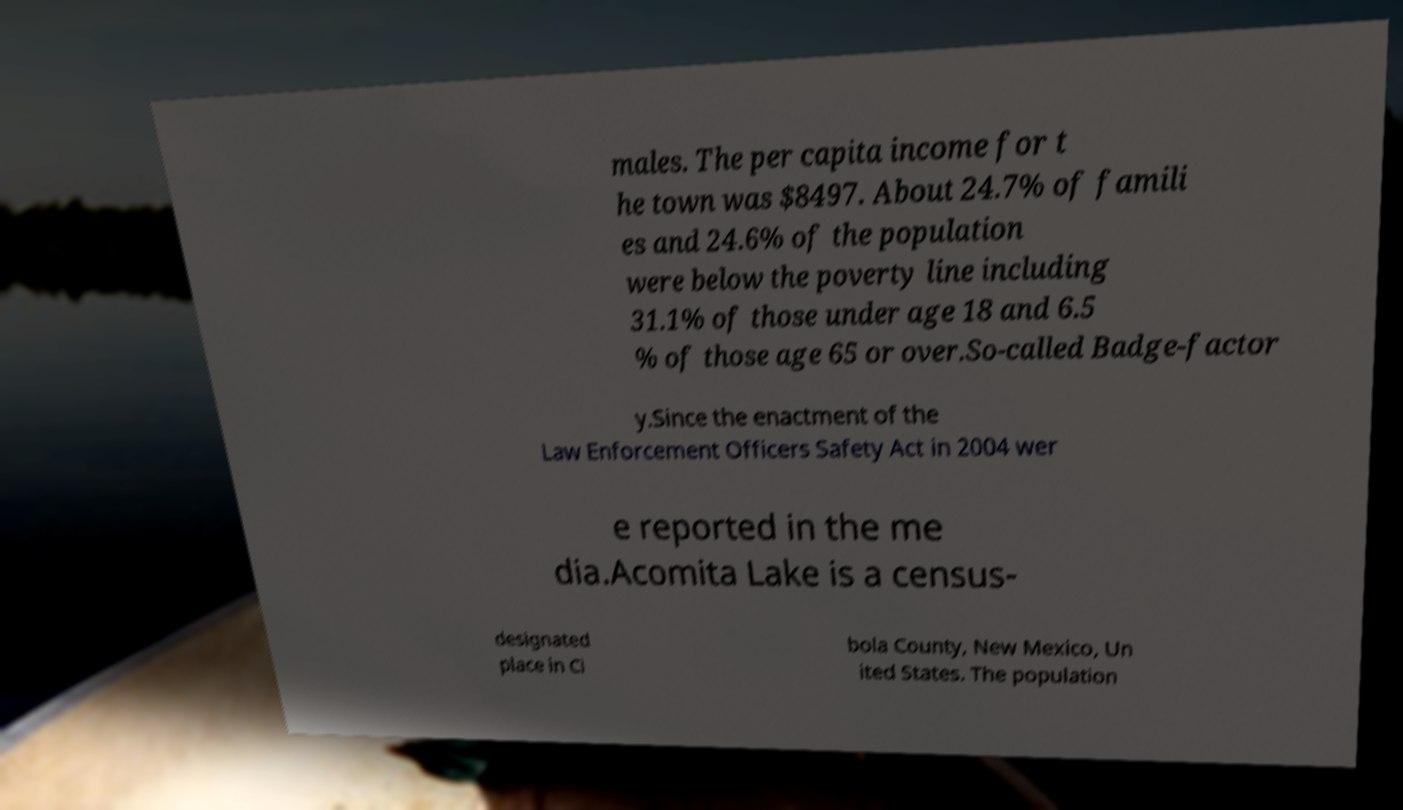Please identify and transcribe the text found in this image. males. The per capita income for t he town was $8497. About 24.7% of famili es and 24.6% of the population were below the poverty line including 31.1% of those under age 18 and 6.5 % of those age 65 or over.So-called Badge-factor y.Since the enactment of the Law Enforcement Officers Safety Act in 2004 wer e reported in the me dia.Acomita Lake is a census- designated place in Ci bola County, New Mexico, Un ited States. The population 